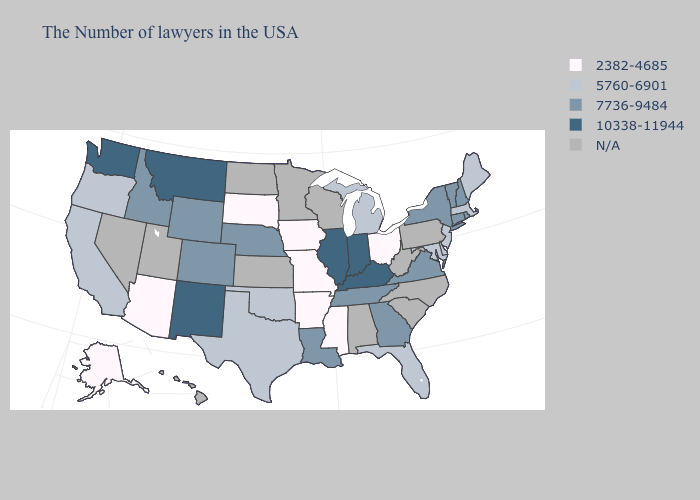Name the states that have a value in the range 5760-6901?
Short answer required. Maine, Massachusetts, New Jersey, Delaware, Maryland, Florida, Michigan, Oklahoma, Texas, California, Oregon. Name the states that have a value in the range 5760-6901?
Give a very brief answer. Maine, Massachusetts, New Jersey, Delaware, Maryland, Florida, Michigan, Oklahoma, Texas, California, Oregon. What is the value of Minnesota?
Be succinct. N/A. Among the states that border Massachusetts , which have the highest value?
Keep it brief. Rhode Island, New Hampshire, Vermont, Connecticut, New York. Name the states that have a value in the range 5760-6901?
Answer briefly. Maine, Massachusetts, New Jersey, Delaware, Maryland, Florida, Michigan, Oklahoma, Texas, California, Oregon. What is the value of Georgia?
Quick response, please. 7736-9484. What is the highest value in states that border Missouri?
Concise answer only. 10338-11944. Is the legend a continuous bar?
Answer briefly. No. Does Vermont have the lowest value in the Northeast?
Write a very short answer. No. What is the lowest value in the USA?
Short answer required. 2382-4685. What is the highest value in the USA?
Quick response, please. 10338-11944. What is the value of New York?
Answer briefly. 7736-9484. Is the legend a continuous bar?
Be succinct. No. 